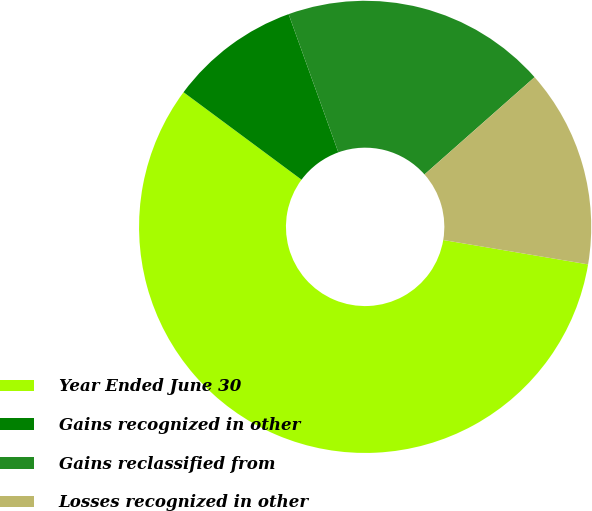Convert chart. <chart><loc_0><loc_0><loc_500><loc_500><pie_chart><fcel>Year Ended June 30<fcel>Gains recognized in other<fcel>Gains reclassified from<fcel>Losses recognized in other<nl><fcel>57.5%<fcel>9.35%<fcel>18.98%<fcel>14.17%<nl></chart> 